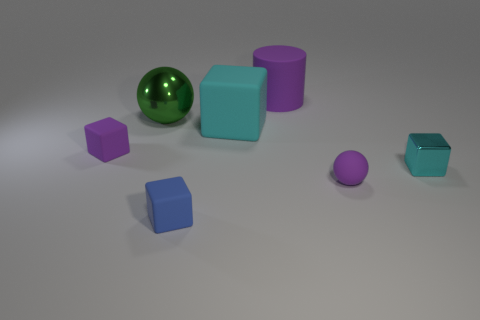Subtract 1 blocks. How many blocks are left? 3 Add 2 large red metal things. How many objects exist? 9 Subtract all cylinders. How many objects are left? 6 Add 1 rubber cubes. How many rubber cubes exist? 4 Subtract 0 blue balls. How many objects are left? 7 Subtract all cyan things. Subtract all big shiny things. How many objects are left? 4 Add 4 tiny cyan cubes. How many tiny cyan cubes are left? 5 